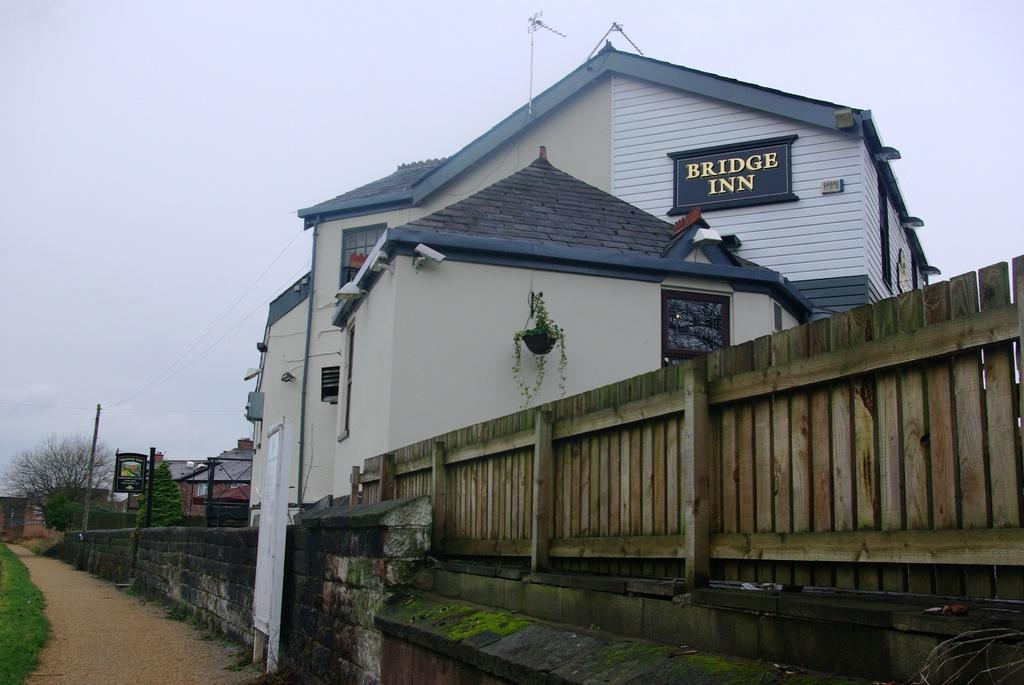What type of fencing is present in the image? There is a wooden fencing in the image. What other structures can be seen in the image? There is a wall and a building in the image. What part of the natural environment is visible in the image? The sky is visible in the image. How would you describe the weather based on the sky in the image? The sky is cloudy in the image. Where is the oven located in the image? There is no oven present in the image. What type of drain can be seen in the image? There is no drain present in the image. 